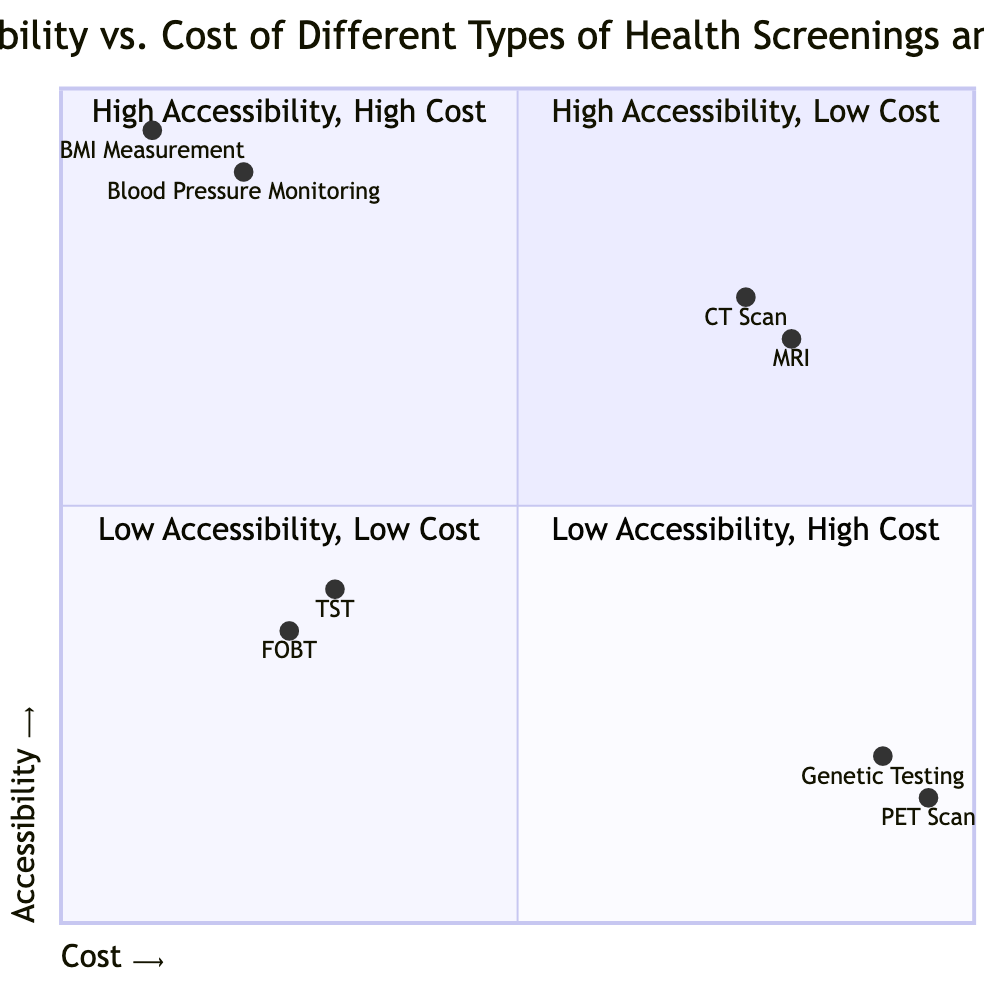What types of screenings are in the high accessibility, low cost quadrant? In the quadrant labeled "High Accessibility, Low Cost," we have two screenings listed: "Blood Pressure Monitoring" and "Body Mass Index (BMI) Measurement." These are listed directly under this quadrant title in the diagram.
Answer: Blood Pressure Monitoring, Body Mass Index (BMI) Measurement How many screenings are categorized as high cost? In the quadrant labeled "High Cost," there are two screenings: "MRI" and "CT Scan." This can be directly counted from the respective quadrants that specify high cost.
Answer: 2 Which screening has the highest cost and the lowest accessibility? The screening with the highest cost and lowest accessibility is "PET Scan." This is indicated in the "Low Accessibility, High Cost" quadrant where the screening is explicitly mentioned.
Answer: PET Scan What is the average cost position of the screenings in the "High Accessibility, High Cost" quadrant? Both screenings in the "High Accessibility, High Cost" quadrant, "MRI" and "CT Scan," are positioned at 0.8 and 0.75 on the cost axis, respectively. The average cost can be calculated by finding the mean of these two values: (0.8 + 0.75) / 2 = 0.775.
Answer: 0.775 Which screening has the lowest accessibility? The screening with the lowest accessibility is "PET Scan," which is found in the "Low Accessibility, High Cost" quadrant. Its accessibility value is noted as 0.15, which is the lowest point on the y-axis for listed screenings.
Answer: PET Scan What is the relationship between cost and accessibility for "Blood Pressure Monitoring"? "Blood Pressure Monitoring" is located in the "High Accessibility, Low Cost" quadrant, which indicates that it has both low cost and high accessibility. Therefore, the relationship is positive, showcasing a favorable approach for health screenings.
Answer: High Accessibility, Low Cost Which screening is less accessible than the Fecal Occult Blood Test (FOBT)? The screening that is less accessible than "Fecal Occult Blood Test (FOBT)," which is in the "Low Accessibility, Low Cost" quadrant at an accessibility value of around 0.35, is "TST (Tuberculin Skin Test)" found in the same quadrant at 0.4, meaning FOBT is more accessible.
Answer: None What is the description for the screening in the "High Accessibility, High Cost" quadrant? In the "High Accessibility, High Cost" quadrant, both "MRI" and "CT Scan" have descriptions indicating they are widely accessible at major hospitals but carry a high cost, as noted in their respective descriptions listed in the diagram.
Answer: Available at most major hospitals and diagnostic centers, but expensive / Similarly accessible in hospitals and diagnostic labs, yet carries a high cost 